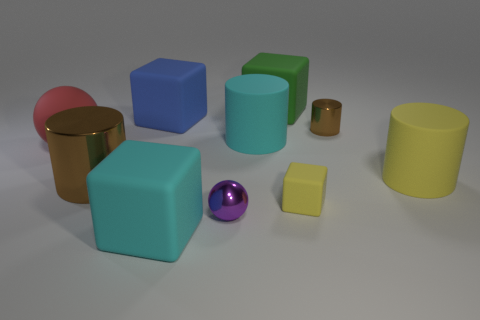Subtract 1 cylinders. How many cylinders are left? 3 Subtract all cyan cylinders. How many cylinders are left? 3 Subtract all purple blocks. Subtract all yellow cylinders. How many blocks are left? 4 Subtract all cylinders. How many objects are left? 6 Subtract all cylinders. Subtract all tiny cyan metallic things. How many objects are left? 6 Add 2 metal cylinders. How many metal cylinders are left? 4 Add 3 big cyan rubber spheres. How many big cyan rubber spheres exist? 3 Subtract 1 yellow blocks. How many objects are left? 9 